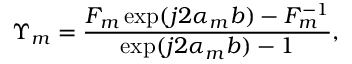<formula> <loc_0><loc_0><loc_500><loc_500>\Upsilon _ { m } = \frac { F _ { m } \exp ( j 2 \alpha _ { m } b ) - F _ { m } ^ { - 1 } } { \exp ( j 2 \alpha _ { m } b ) - 1 } ,</formula> 